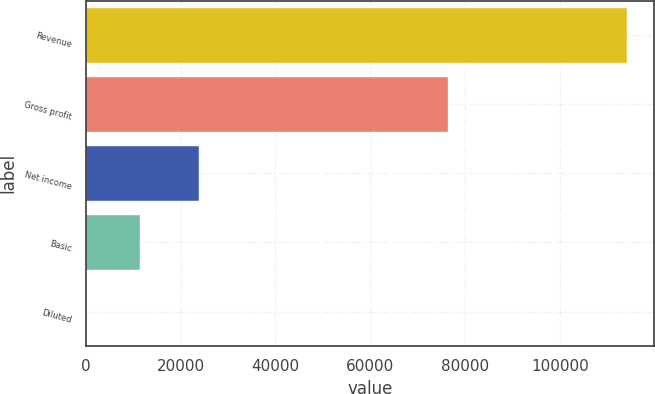<chart> <loc_0><loc_0><loc_500><loc_500><bar_chart><fcel>Revenue<fcel>Gross profit<fcel>Net income<fcel>Basic<fcel>Diluted<nl><fcel>114229<fcel>76508<fcel>23802<fcel>11423.5<fcel>0.62<nl></chart> 